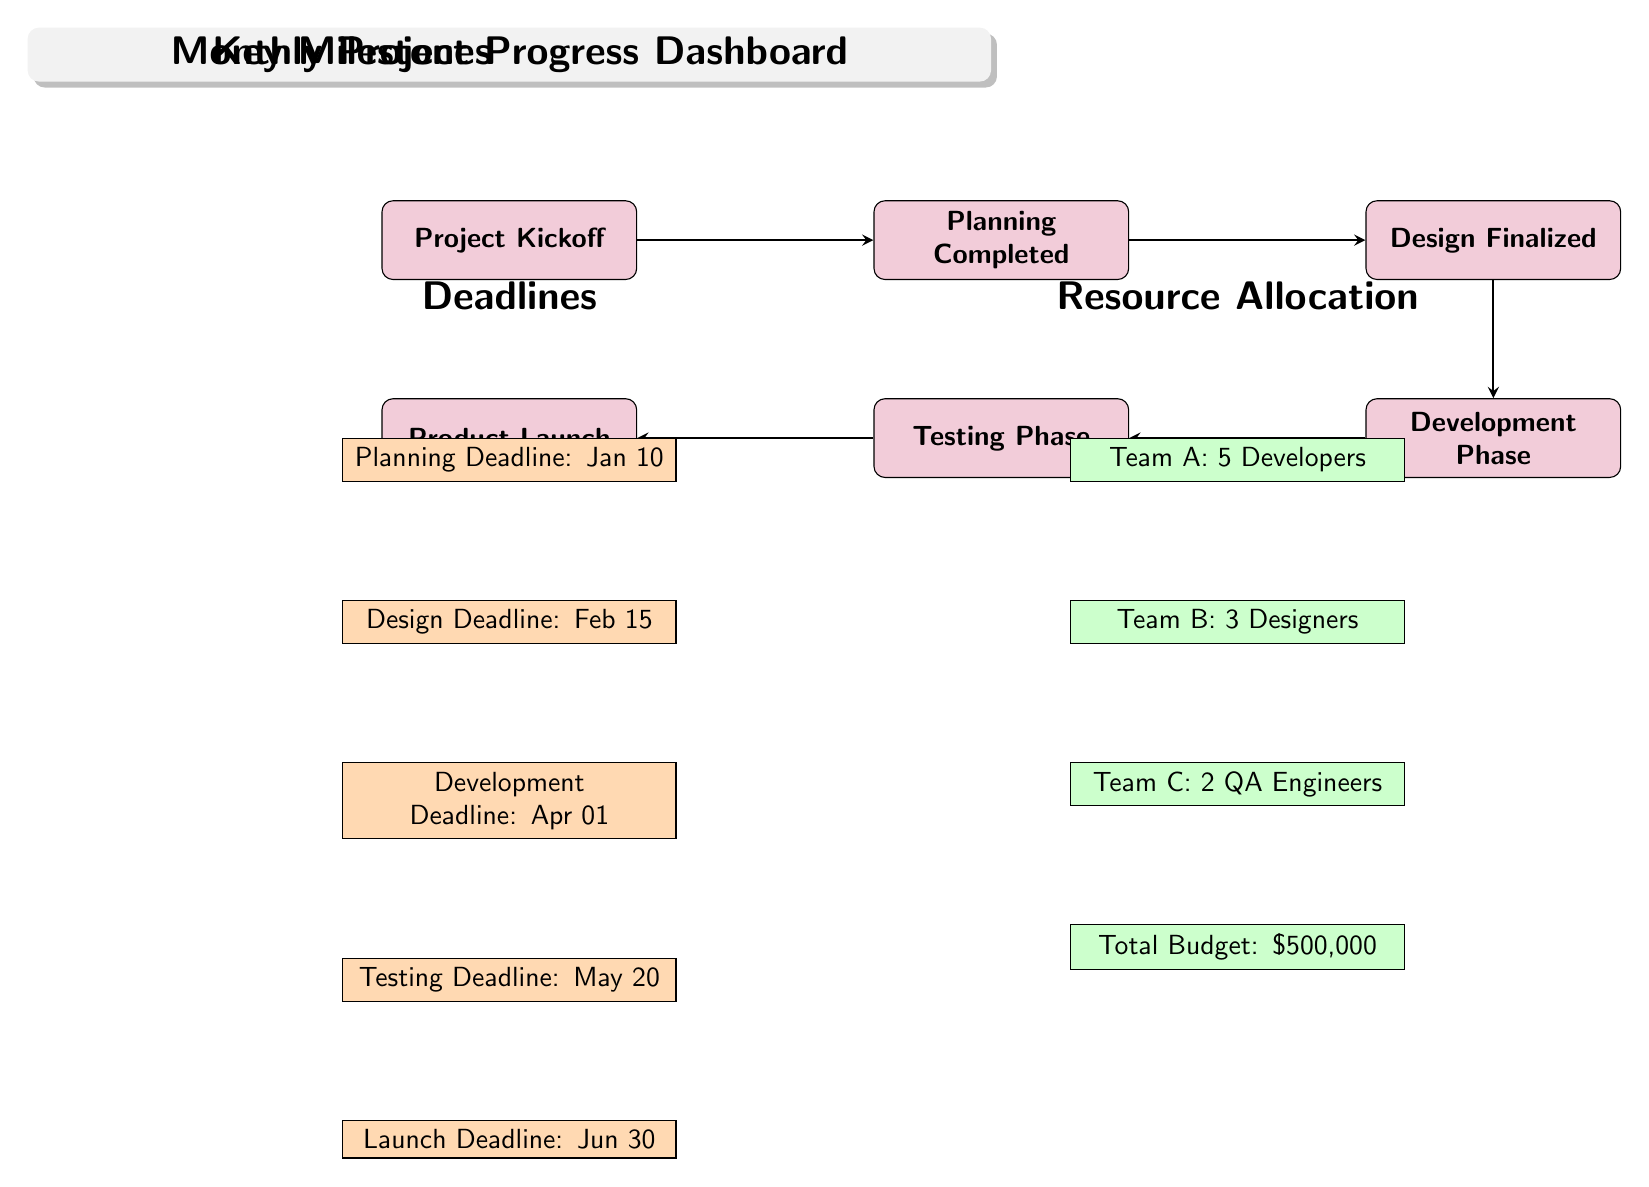What is the first milestone in the project? The first milestone is labeled "Project Kickoff" and is the starting point in the flow of milestones illustrated in the diagram.
Answer: Project Kickoff What is the deadline for the development phase? The diagram indicates that the "Development Deadline" is set for April 1, as listed directly below the milestone related to the development phase.
Answer: Apr 01 Which team has the highest number of members allocated? Looking at the resource allocation section of the diagram, "Team A: 5 Developers" is shown to have the highest count of team members compared to others listed below it.
Answer: Team A: 5 Developers What is the relationship between the design milestone and its corresponding deadline? The "Design Finalized" milestone is linked to the "Design Deadline" (February 15) by a direct connection. This shows that once the design milestone is reached, it corresponds with its deadline, indicating an important timeline sequence.
Answer: Design Deadline: Feb 15 How many total teams are involved in this project? By examining the resource allocation section, there are three different teams specified: Team A, Team B, and Team C, which indicates the diversity in team contributions to the project.
Answer: 3 Teams What is the total budget allocated for the project? The resource allocation section lists "Total Budget: $500,000," which is a crucial figure reflecting the financial resource planned for the project.
Answer: $500,000 What is the final milestone in this project timeline? The final milestone is "Product Launch," which is last in the sequence of milestones and signifies the completion of the project.
Answer: Product Launch Which phase comes after the testing phase? According to the sequence of milestones, the "Product Launch" follows immediately after the "Testing Phase," indicating the final step of project execution.
Answer: Product Launch What deadline comes after the design deadline? The diagram outlines the "Development Deadline" on April 1, which directly follows the "Design Deadline" (February 15), reflecting the project's time flow.
Answer: Apr 01 